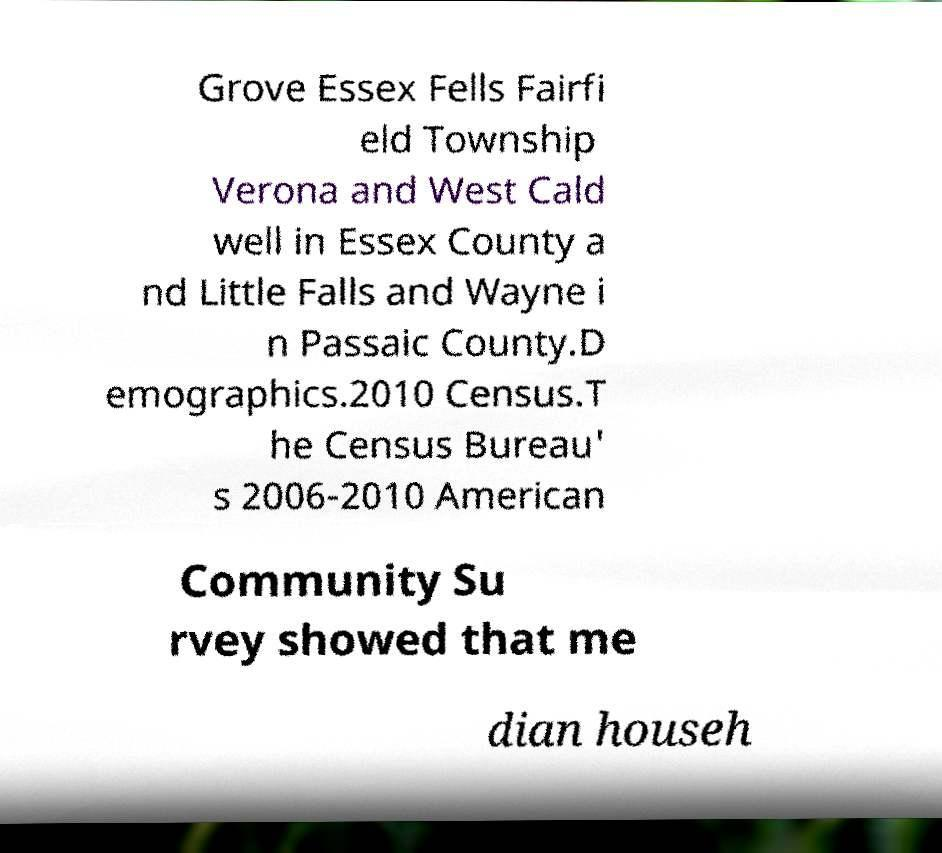I need the written content from this picture converted into text. Can you do that? Grove Essex Fells Fairfi eld Township Verona and West Cald well in Essex County a nd Little Falls and Wayne i n Passaic County.D emographics.2010 Census.T he Census Bureau' s 2006-2010 American Community Su rvey showed that me dian househ 